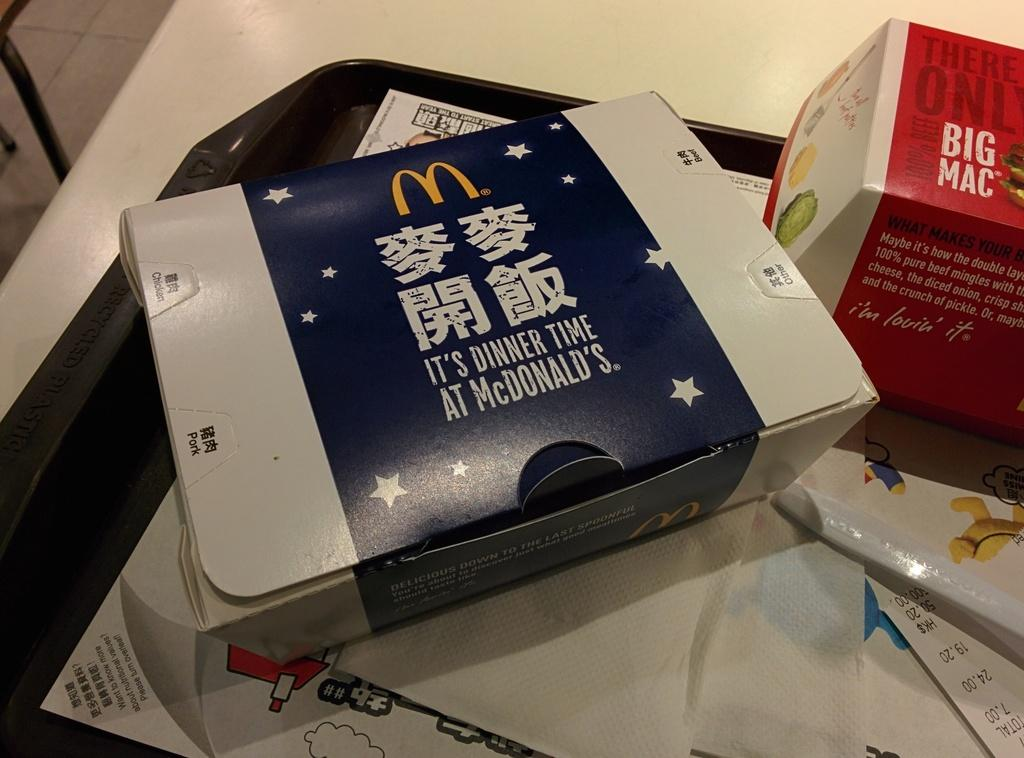Provide a one-sentence caption for the provided image. mcdonalds food that is in chinese i see a big mac. 